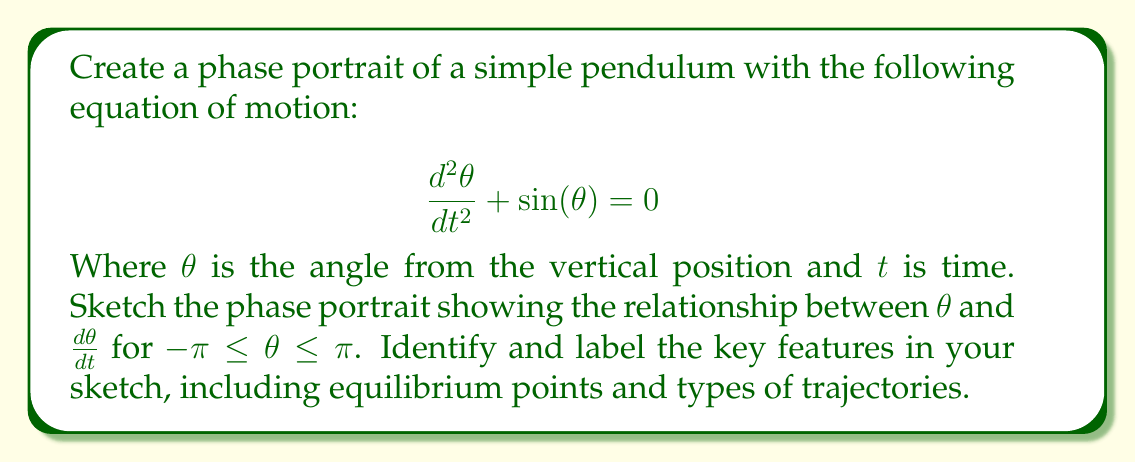Show me your answer to this math problem. To create a phase portrait for the pendulum, we'll follow these steps:

1) First, let's rewrite the second-order differential equation as a system of first-order equations:

   Let $x = \theta$ and $y = \frac{d\theta}{dt}$

   Then, $\frac{dx}{dt} = y$ and $\frac{dy}{dt} = -\sin(x)$

2) Now, we can identify the equilibrium points. These occur when both $\frac{dx}{dt} = 0$ and $\frac{dy}{dt} = 0$:

   $y = 0$ and $\sin(x) = 0$

   This gives us two equilibrium points in our range: $(0,0)$ and $(\pi,0)$

3) The point $(0,0)$ represents the pendulum hanging straight down (stable equilibrium).
   The point $(\pi,0)$ represents the pendulum balanced upright (unstable equilibrium).

4) Now, let's sketch the phase portrait:

[asy]
import graph;
size(200,200);

xaxis("$\theta$",-pi,pi,Arrow);
yaxis("$\frac{d\theta}{dt}$",-3,3,Arrow);

void drawArrow(pair z1, pair z2, real arrowSize=0.5, pen p=currentpen) {
  draw(z1--z2,p,Arrow(arrowSize));
}

for (real y = -2.5; y <= 2.5; y += 0.5) {
  drawArrow((-pi,y), (-pi+0.3,y+0.3*sin(-pi)));
  drawArrow((pi,y), (pi-0.3,y-0.3*sin(pi)));
}

for (real x = -pi+0.3; x < pi; x += 0.3) {
  drawArrow((x,2.5), (x+0.3,2.5-0.3*sin(x)));
  drawArrow((x,-2.5), (x+0.3,-2.5-0.3*sin(x)));
}

draw((-pi,-2.5)--(-pi,2.5),dashed);
draw((pi,-2.5)--(pi,2.5),dashed);

dot((0,0));
dot((pi,0));
dot((-pi,0));

label("Stable", (0,-0.5), S);
label("Unstable", (pi,-0.5), S);
label("Unstable", (-pi,-0.5), S);

path separator = (0,2.3){right}..{down}(1.2,0){down}..{left}(0,-2.3);
draw(separator);
draw(reflect(O,N)*separator);
[/asy]

5) Key features to note in the sketch:

   a) The stable equilibrium at (0,0) is a center, with closed orbits around it.
   b) The unstable equilibrium at (π,0) is a saddle point.
   c) The separatrix (the trajectory that separates different behaviors) passes through (π,0).
   d) Closed orbits represent oscillations of the pendulum.
   e) Open trajectories above and below the separatrix represent rotations of the pendulum.

6) The arrows on the trajectories indicate the direction of motion in the phase space.

This phase portrait visually represents all possible motions of the pendulum, from small oscillations near the stable equilibrium to full rotations.
Answer: Phase portrait with stable center at (0,0), unstable saddle at (π,0), closed orbits (oscillations), and open trajectories (rotations). 